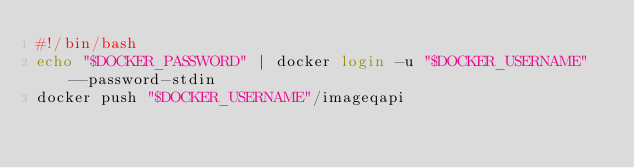Convert code to text. <code><loc_0><loc_0><loc_500><loc_500><_Bash_>#!/bin/bash
echo "$DOCKER_PASSWORD" | docker login -u "$DOCKER_USERNAME" --password-stdin
docker push "$DOCKER_USERNAME"/imageqapi</code> 